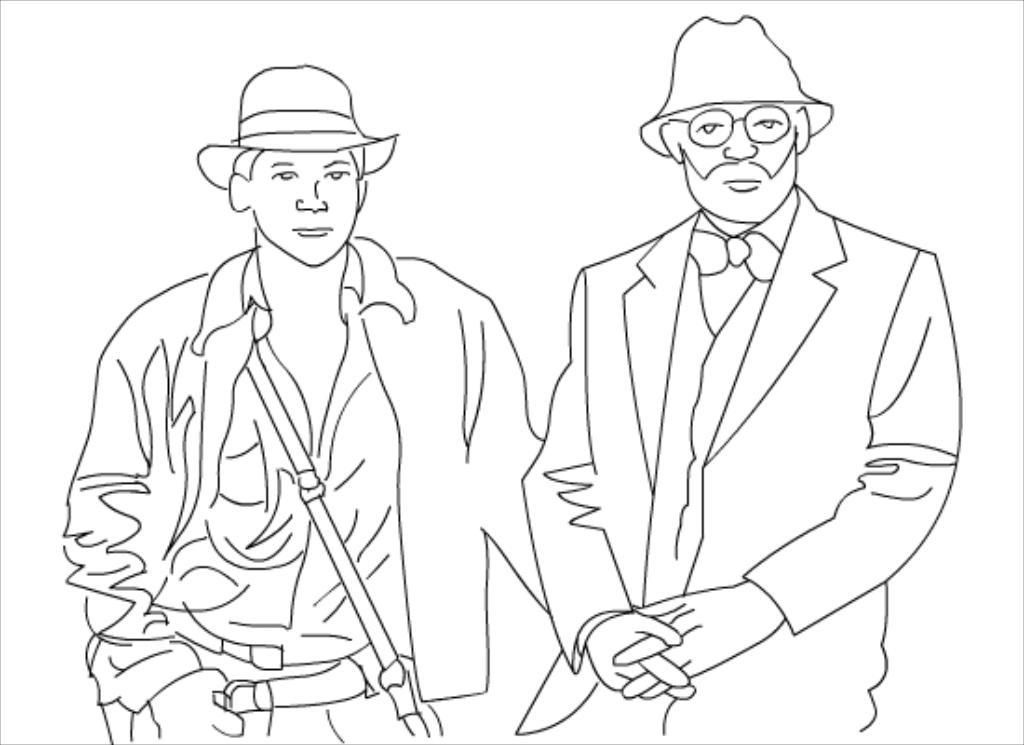What is the main subject of the image? The main subject of the image is two people. What are the two people doing in the image? The two people are engaged in some form of art. What are the people wearing on their heads? The people are wearing hats. What color is the background of the image? The background of the image is white. How many clovers can be seen growing in the image? There are no clovers present in the image; it features two people engaged in some form of art against a white background. 